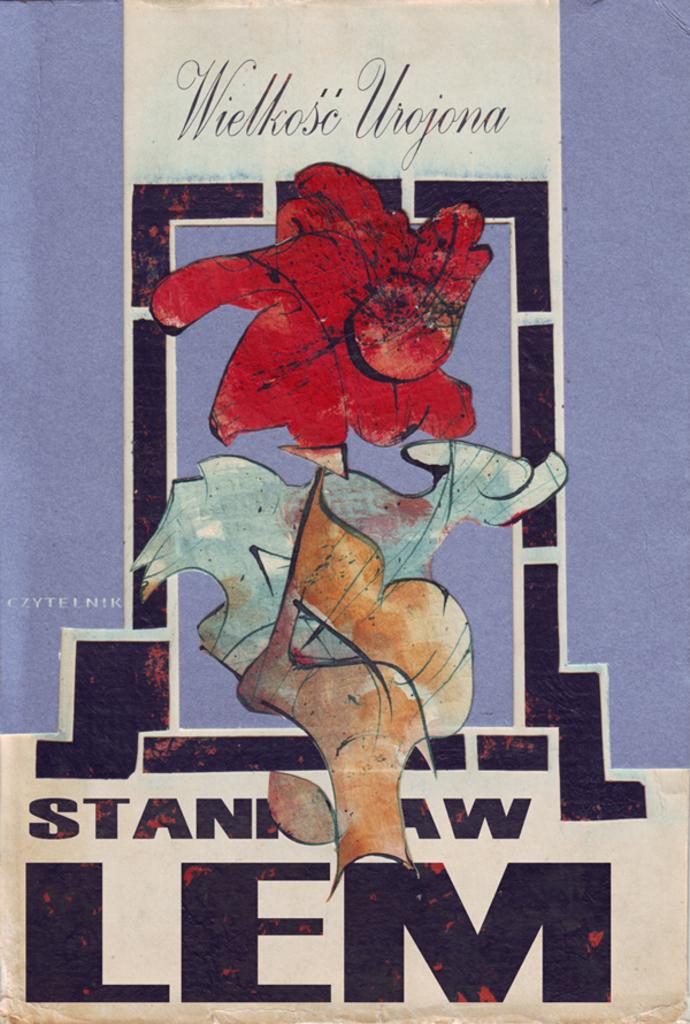What type of visual is the image? The image is a poster. What can be found on the poster besides the visual elements? There is text on the poster. What else is depicted on the poster besides the text? There are objects on the poster. What type of crate is shown in the image? There is no crate present in the image. What sounds can be heard coming from the objects on the poster? The image is a static poster, so no sounds can be heard from the objects. 